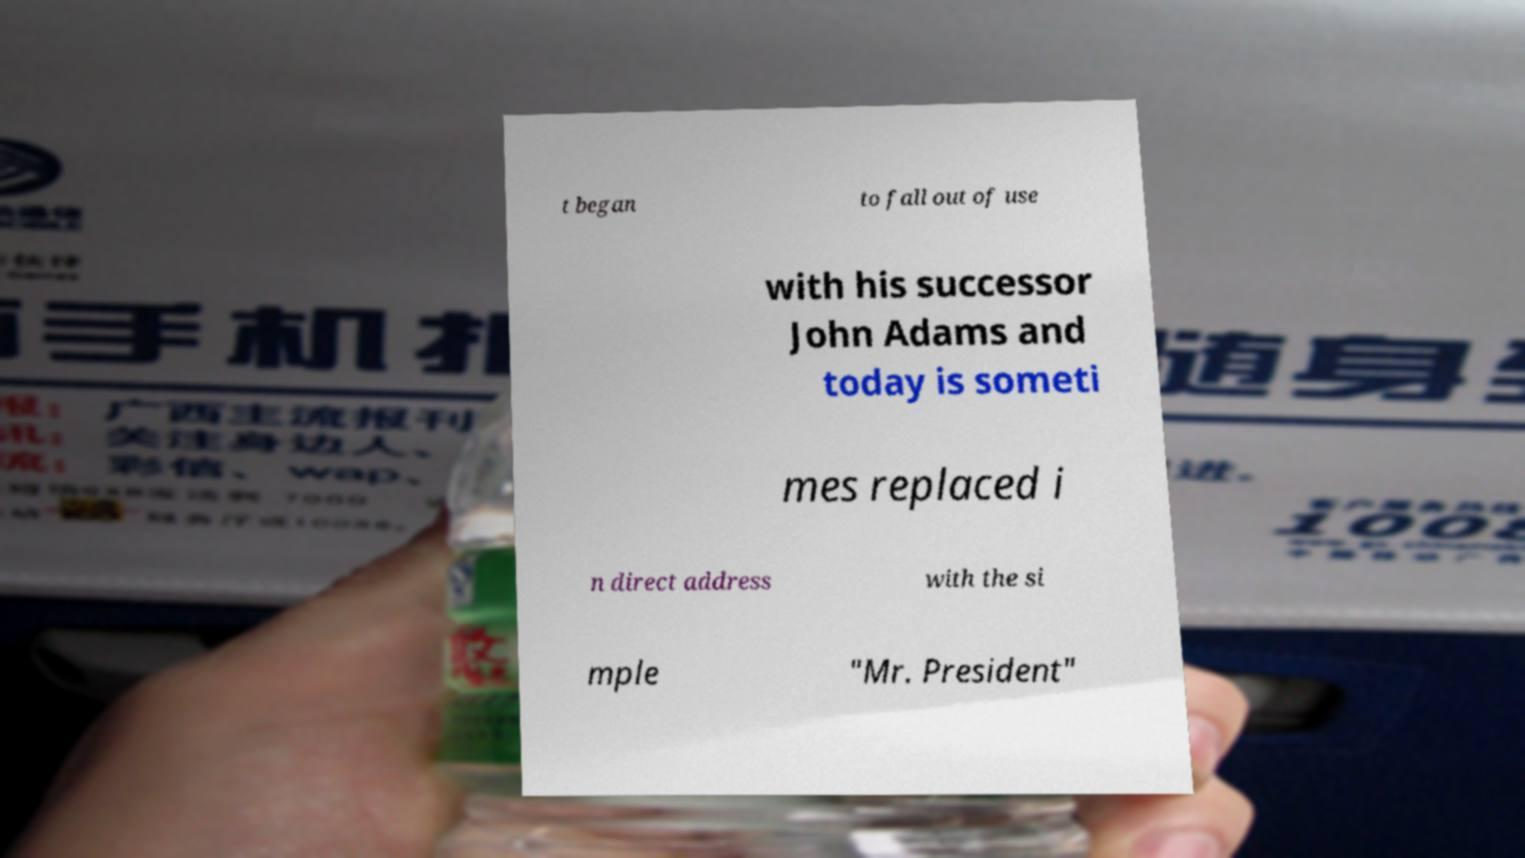Could you assist in decoding the text presented in this image and type it out clearly? t began to fall out of use with his successor John Adams and today is someti mes replaced i n direct address with the si mple "Mr. President" 